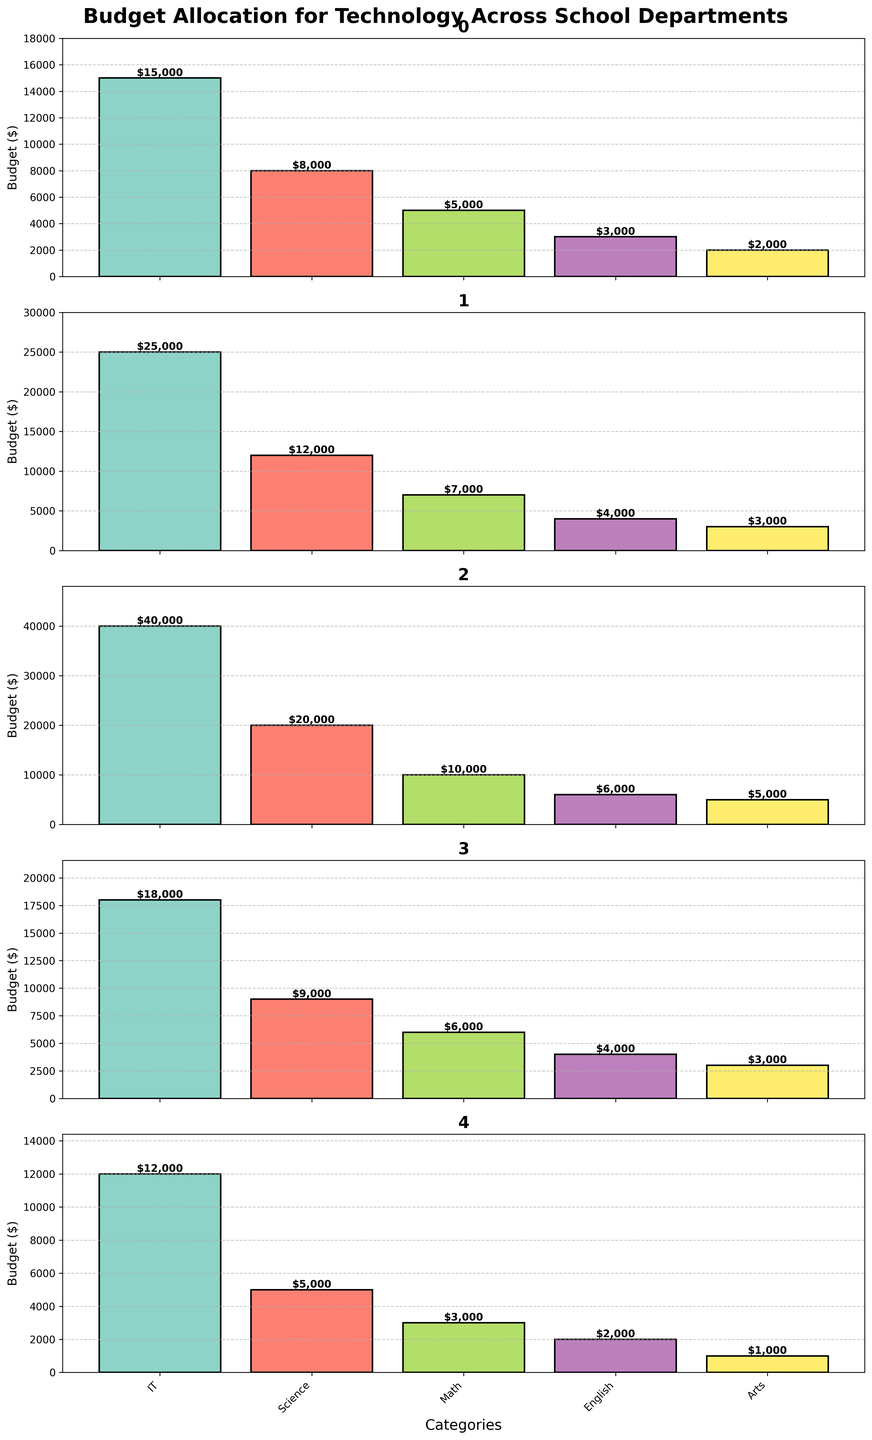Which department allocates the highest budget for IT? By looking at the heights of the bars for the IT budget across all departments, the High School has the tallest bar, indicating the highest allocation at $40,000.
Answer: High School Which department spends the least on Arts? By comparing the heights of the bars representing the Arts budget, the Adult Education department has the shortest bar at $1,000.
Answer: Adult Education What is the total budget allocation for technology in the Elementary department? Sum the values for IT, Science, Math, English, and Arts in the Elementary department: 15000 + 8000 + 5000 + 3000 + 2000 = $33,000.
Answer: $33,000 How does the Math budget in Middle School compare to the Math budget in High School? By looking at the heights of the Math bars for both schools, the Middle School allocates $7,000 and the High School allocates $10,000. Thus, the High School spends more on Math.
Answer: High School spends more Which department’s Science budget is exactly double the Math budget? By checking the values, the Science budget in the High School is $20,000, which is double its Math budget of $10,000.
Answer: High School What is the average budget for IT across all departments? Sum the IT budgets across all departments: 15000 + 25000 + 40000 + 18000 + 12000 = 110,000. Divide by the number of departments (5), 110000 / 5 = $22,000.
Answer: $22,000 Compare the English budget in Elementary to the English budget in High School. The English budget is displayed as $3,000 for Elementary and $6,000 for High School. Therefore, the High School allocates more to English.
Answer: High School allocates more Is the total budget for Science greater than that for English in the Middle School? Sum the budgets in Middle School: Science = $12,000 and English = $4,000. Since 12000 > 4000, the Science budget is greater.
Answer: Yes, Science is greater Which category has the highest overall budget allocation across all departments? Sum the budgets for each category across all departments: IT(15000+25000+40000+18000+12000) = 110000, Science(8000+12000+20000+9000+5000) = 54000, Math(5000+7000+10000+6000+3000) = 31000, English(3000+4000+6000+4000+2000) = 19000, Arts(2000+3000+5000+3000+1000) = 14000. IT has the highest total at $110,000.
Answer: IT Comparing the Adult Education department, which category shows the highest allocation? The bars for IT budget shows $12,000 which is higher than the others in the Adult Education department.
Answer: IT 